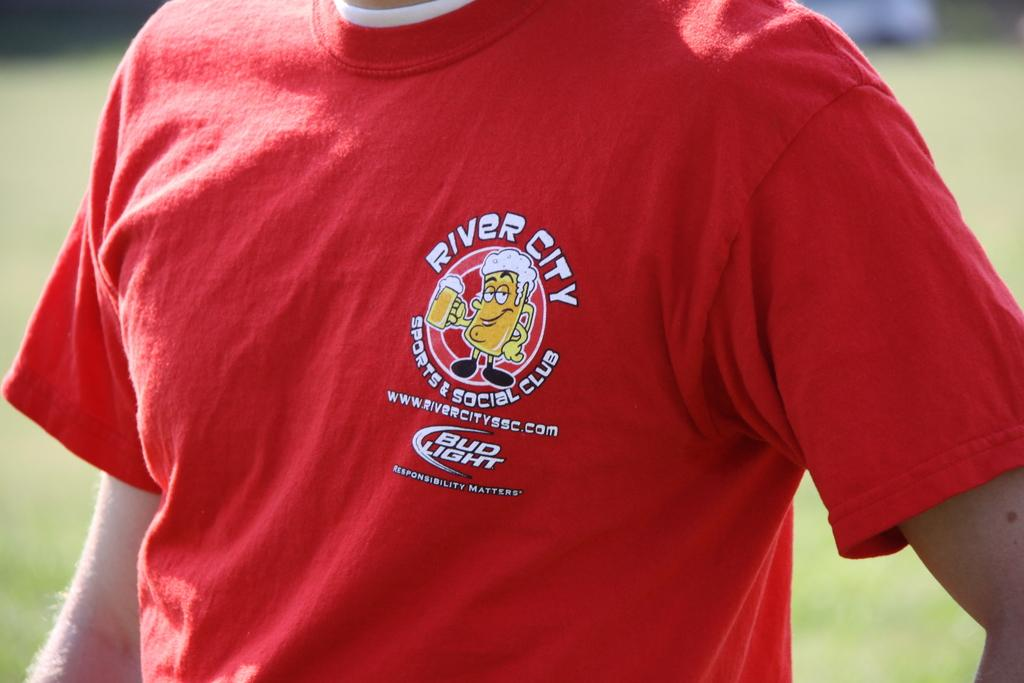Provide a one-sentence caption for the provided image. A man is wearing a red shirt sponsored by Bud Light. 